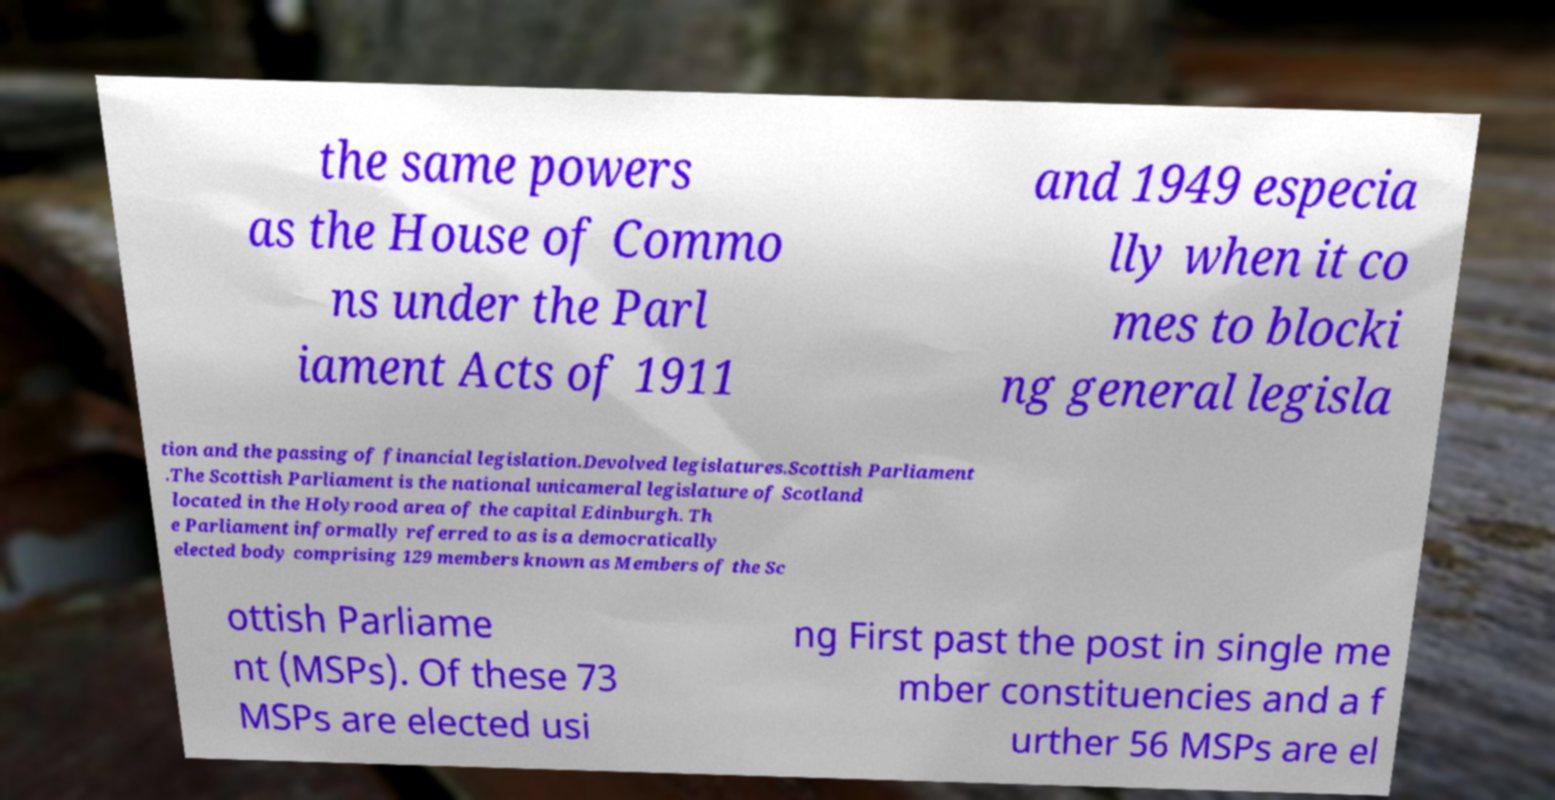For documentation purposes, I need the text within this image transcribed. Could you provide that? the same powers as the House of Commo ns under the Parl iament Acts of 1911 and 1949 especia lly when it co mes to blocki ng general legisla tion and the passing of financial legislation.Devolved legislatures.Scottish Parliament .The Scottish Parliament is the national unicameral legislature of Scotland located in the Holyrood area of the capital Edinburgh. Th e Parliament informally referred to as is a democratically elected body comprising 129 members known as Members of the Sc ottish Parliame nt (MSPs). Of these 73 MSPs are elected usi ng First past the post in single me mber constituencies and a f urther 56 MSPs are el 